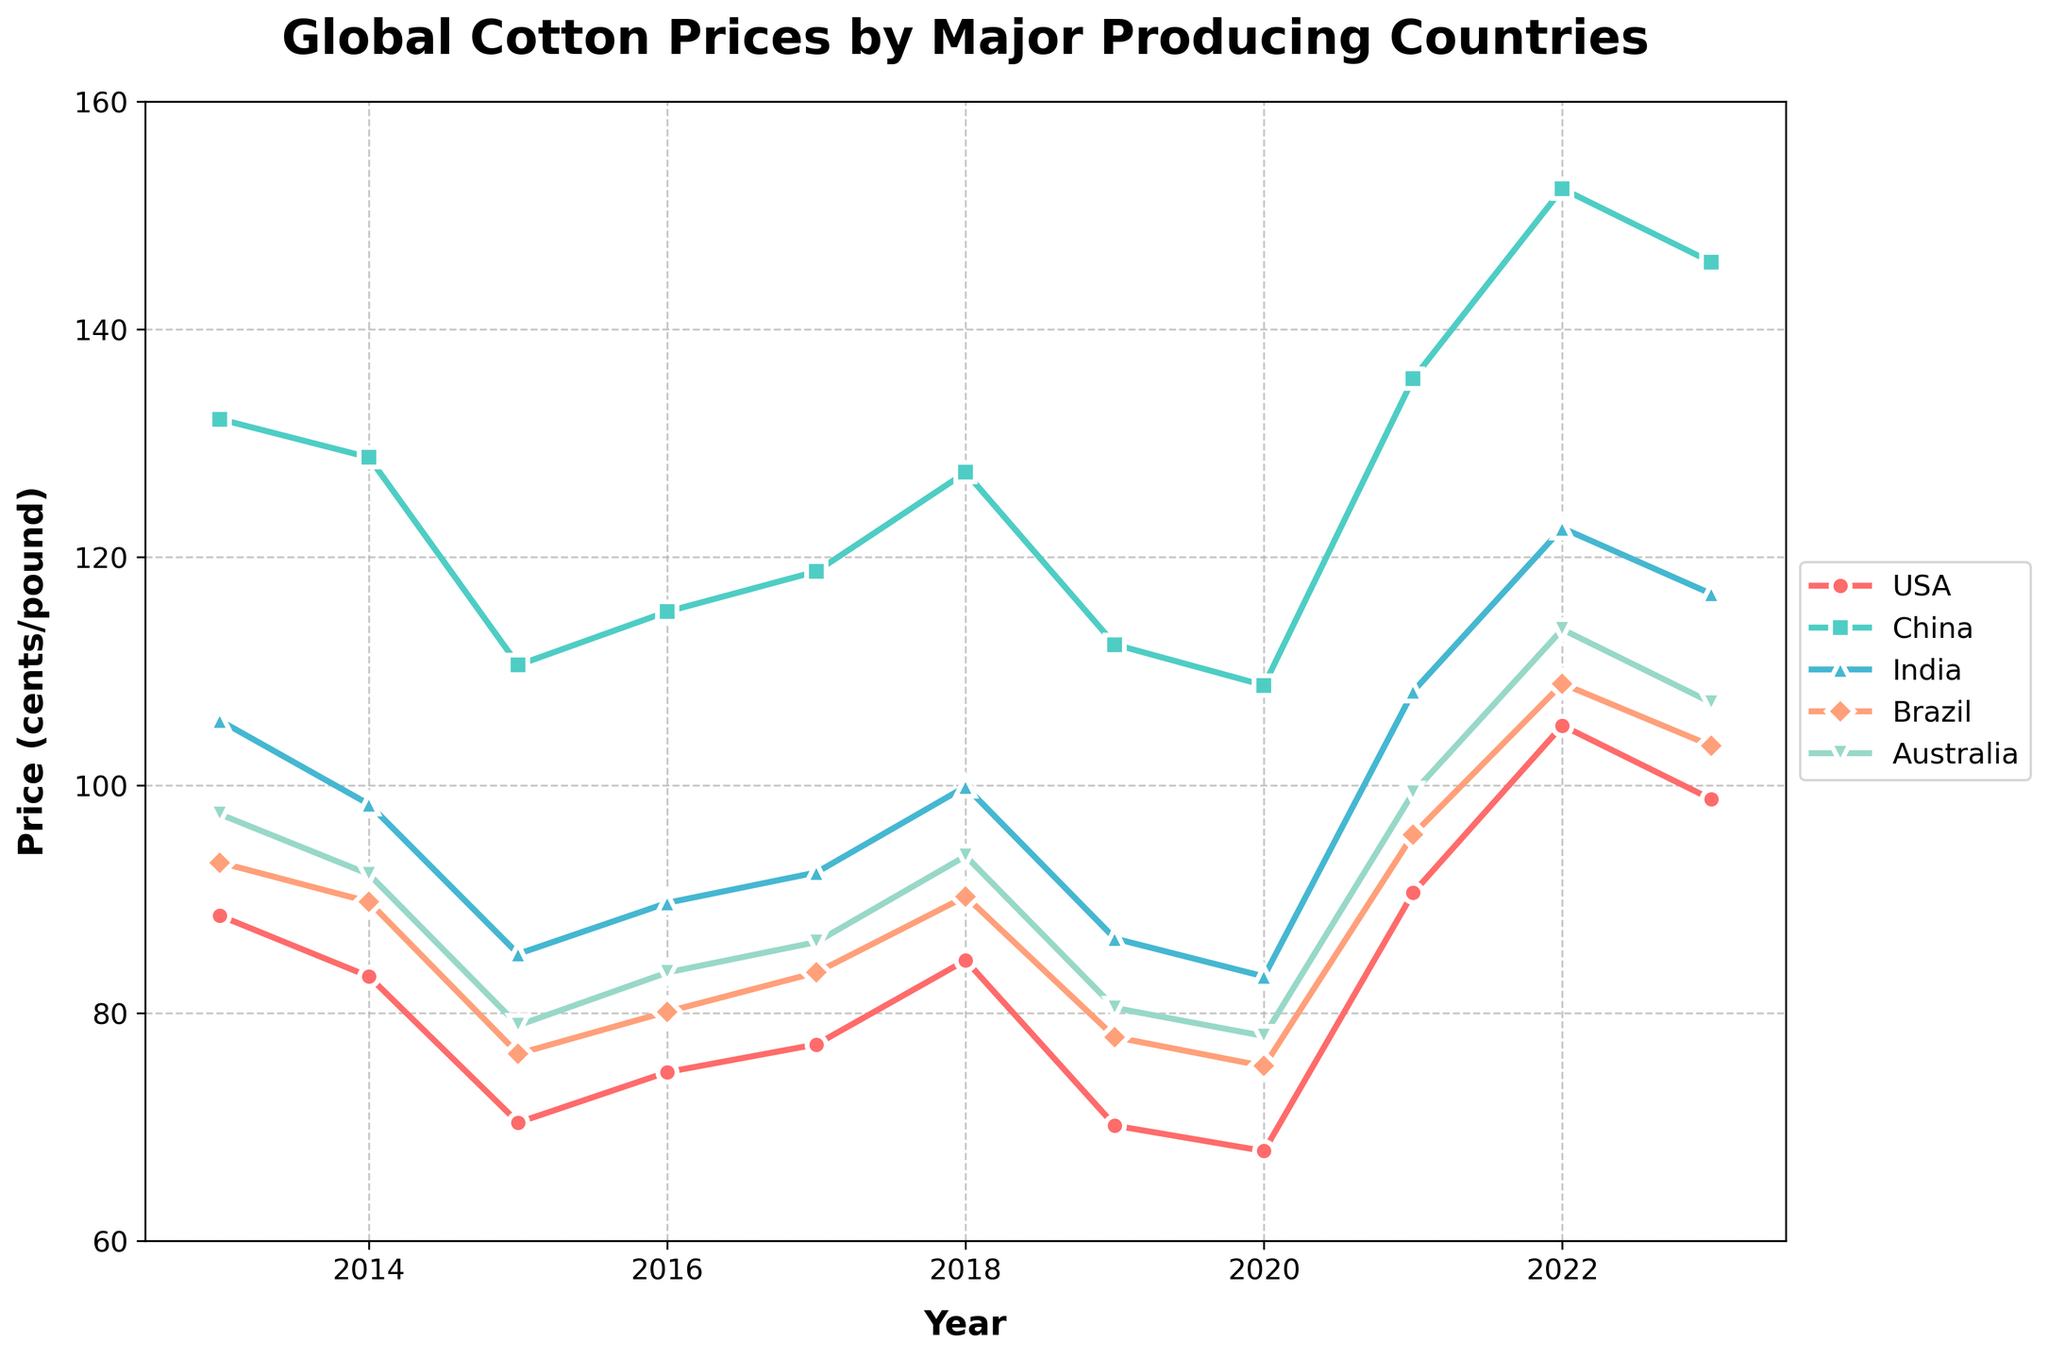What's the trend in cotton prices for Brazil between 2016 and 2023? To determine the trend, observe the line corresponding to Brazil from 2016 to 2023. Note the values: 80.12 (2016), 83.56 (2017), 90.23 (2018), 77.89 (2019), 75.34 (2020), 95.67 (2021), 108.90 (2022), and 103.45 (2023). Overall, there is a rising trend from 2016 to 2023.
Answer: Rising trend Which country had the highest cotton price in 2015? To find this, compare the values for all countries in the year 2015. USA is 70.39, China is 110.54, India is 85.19, Brazil is 76.43, and Australia is 78.92. China has the highest cotton price in 2015.
Answer: China Between USA and Australia, which had a greater increase in cotton prices from 2020 to 2021? For USA, cotton prices increased from 67.89 (2020) to 90.56 (2021), a difference of 22.67. For Australia, prices increased from 77.98 (2020) to 99.34 (2021), a difference of 21.36. USA had a greater increase.
Answer: USA What is the average cotton price in 2022 across all major producers? To calculate the average, sum the cotton prices for each country in 2022: 105.23 (USA) + 152.34 (China) + 122.56 (India) + 108.90 (Brazil) + 113.67 (Australia) = 602.70. Divide by 5 (number of countries): 602.70 / 5 = 120.54.
Answer: 120.54 What is the range of cotton prices for China from 2013 to 2023? The range is calculated by subtracting the minimum value from the maximum value within the period for China. The values are: 132.12 (2013), 128.76 (2014), 110.54 (2015), 115.23 (2016), 118.76 (2017), 127.45 (2018), 112.34 (2019), 108.76 (2020), 135.67 (2021), 152.34 (2022), and 145.89 (2023). The range is 152.34 (2022) - 108.76 (2020) = 43.58.
Answer: 43.58 How does the cotton price in India for 2016 compare to that in 2023? In 2016, the cotton price in India was 89.67, and in 2023 it was 116.78. So, the price increased by 116.78 - 89.67 = 27.11.
Answer: Increased by 27.11 Which color represents the cotton price trend for Australia? Identify the color used for the Australia line in the plot, which is a light shade of blue.
Answer: Blue In which year did USA cotton prices peak over the given period? To find this, look at the highest point on the line representing the USA. It peaks at 105.23 in 2022.
Answer: 2022 